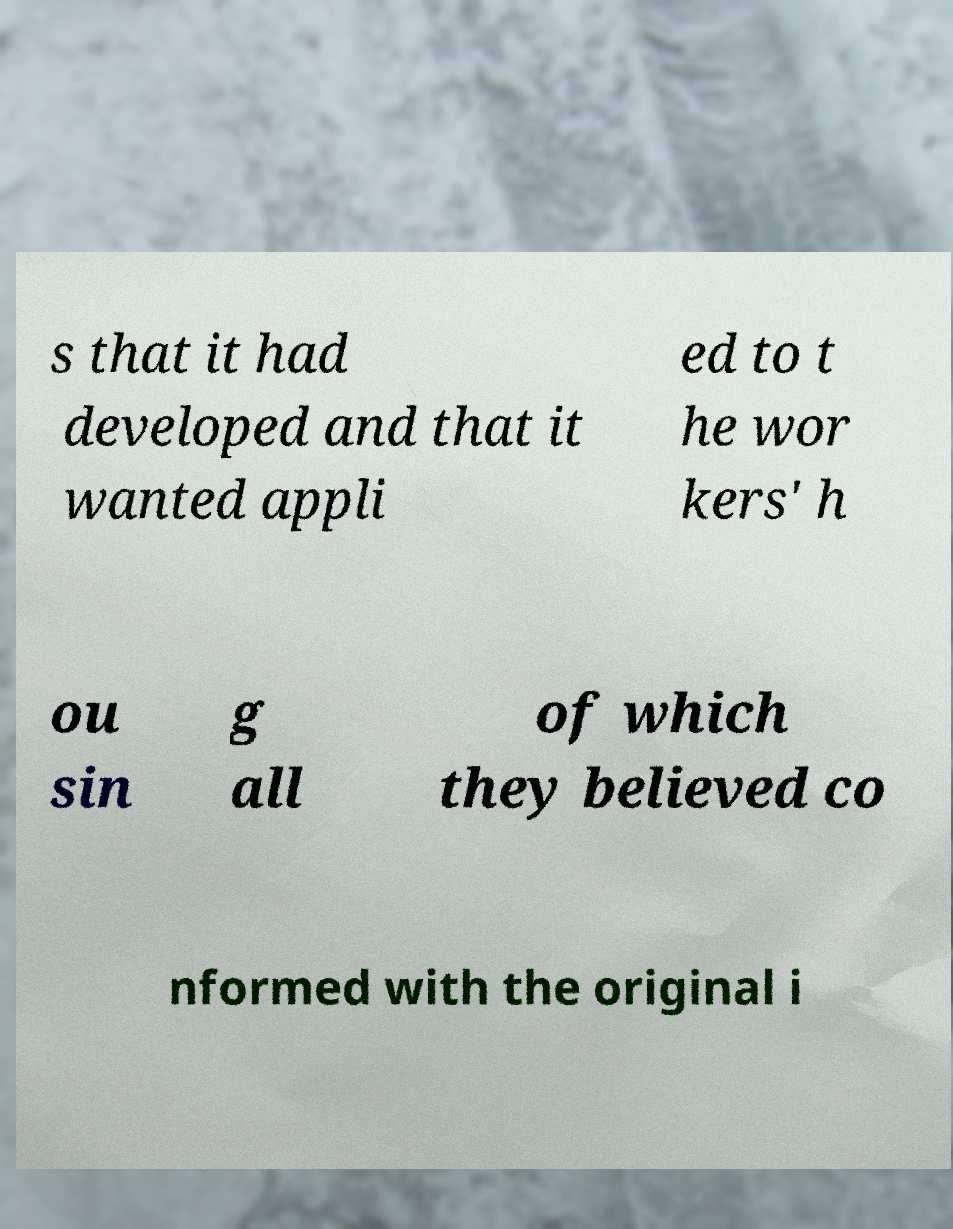Can you accurately transcribe the text from the provided image for me? s that it had developed and that it wanted appli ed to t he wor kers' h ou sin g all of which they believed co nformed with the original i 